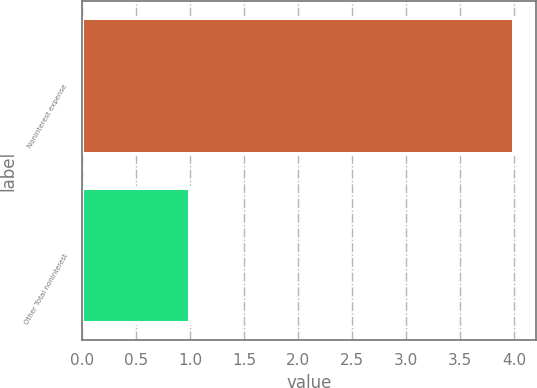Convert chart to OTSL. <chart><loc_0><loc_0><loc_500><loc_500><bar_chart><fcel>Noninterest expense<fcel>Other Total noninterest<nl><fcel>4<fcel>1<nl></chart> 